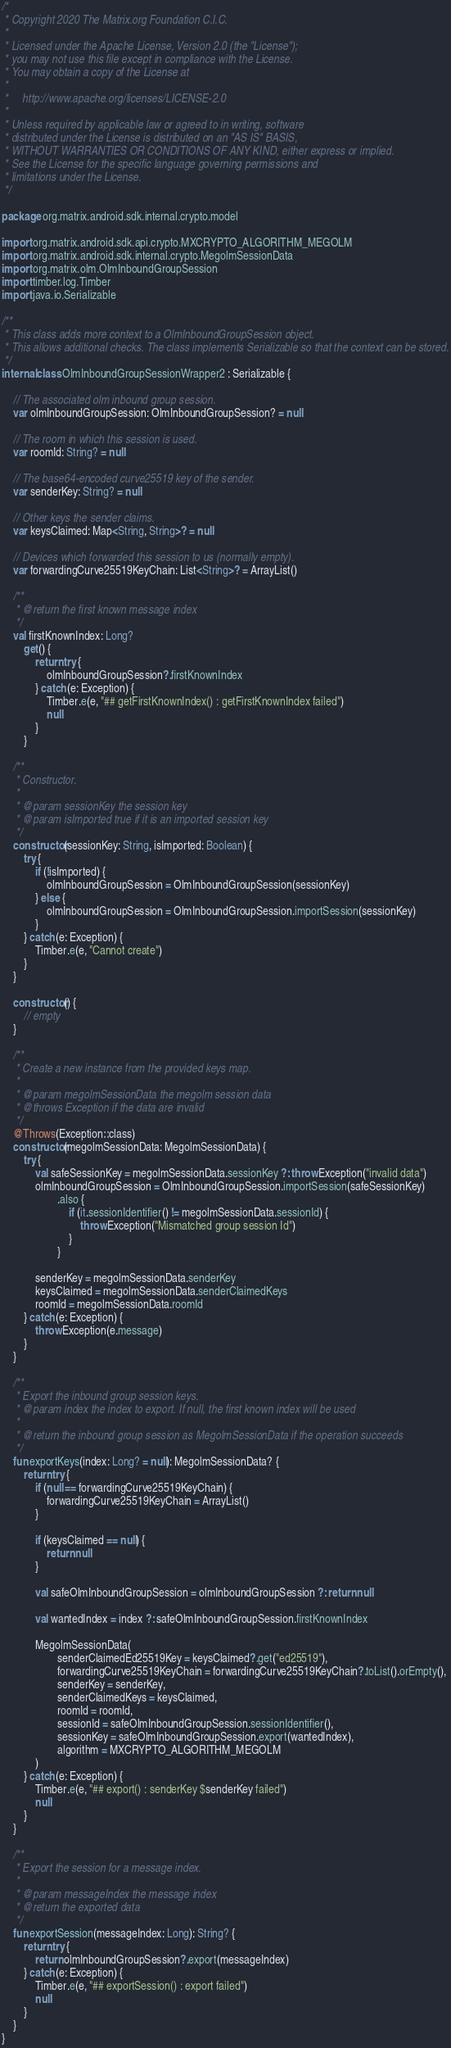Convert code to text. <code><loc_0><loc_0><loc_500><loc_500><_Kotlin_>/*
 * Copyright 2020 The Matrix.org Foundation C.I.C.
 *
 * Licensed under the Apache License, Version 2.0 (the "License");
 * you may not use this file except in compliance with the License.
 * You may obtain a copy of the License at
 *
 *     http://www.apache.org/licenses/LICENSE-2.0
 *
 * Unless required by applicable law or agreed to in writing, software
 * distributed under the License is distributed on an "AS IS" BASIS,
 * WITHOUT WARRANTIES OR CONDITIONS OF ANY KIND, either express or implied.
 * See the License for the specific language governing permissions and
 * limitations under the License.
 */

package org.matrix.android.sdk.internal.crypto.model

import org.matrix.android.sdk.api.crypto.MXCRYPTO_ALGORITHM_MEGOLM
import org.matrix.android.sdk.internal.crypto.MegolmSessionData
import org.matrix.olm.OlmInboundGroupSession
import timber.log.Timber
import java.io.Serializable

/**
 * This class adds more context to a OlmInboundGroupSession object.
 * This allows additional checks. The class implements Serializable so that the context can be stored.
 */
internal class OlmInboundGroupSessionWrapper2 : Serializable {

    // The associated olm inbound group session.
    var olmInboundGroupSession: OlmInboundGroupSession? = null

    // The room in which this session is used.
    var roomId: String? = null

    // The base64-encoded curve25519 key of the sender.
    var senderKey: String? = null

    // Other keys the sender claims.
    var keysClaimed: Map<String, String>? = null

    // Devices which forwarded this session to us (normally empty).
    var forwardingCurve25519KeyChain: List<String>? = ArrayList()

    /**
     * @return the first known message index
     */
    val firstKnownIndex: Long?
        get() {
            return try {
                olmInboundGroupSession?.firstKnownIndex
            } catch (e: Exception) {
                Timber.e(e, "## getFirstKnownIndex() : getFirstKnownIndex failed")
                null
            }
        }

    /**
     * Constructor.
     *
     * @param sessionKey the session key
     * @param isImported true if it is an imported session key
     */
    constructor(sessionKey: String, isImported: Boolean) {
        try {
            if (!isImported) {
                olmInboundGroupSession = OlmInboundGroupSession(sessionKey)
            } else {
                olmInboundGroupSession = OlmInboundGroupSession.importSession(sessionKey)
            }
        } catch (e: Exception) {
            Timber.e(e, "Cannot create")
        }
    }

    constructor() {
        // empty
    }

    /**
     * Create a new instance from the provided keys map.
     *
     * @param megolmSessionData the megolm session data
     * @throws Exception if the data are invalid
     */
    @Throws(Exception::class)
    constructor(megolmSessionData: MegolmSessionData) {
        try {
            val safeSessionKey = megolmSessionData.sessionKey ?: throw Exception("invalid data")
            olmInboundGroupSession = OlmInboundGroupSession.importSession(safeSessionKey)
                    .also {
                        if (it.sessionIdentifier() != megolmSessionData.sessionId) {
                            throw Exception("Mismatched group session Id")
                        }
                    }

            senderKey = megolmSessionData.senderKey
            keysClaimed = megolmSessionData.senderClaimedKeys
            roomId = megolmSessionData.roomId
        } catch (e: Exception) {
            throw Exception(e.message)
        }
    }

    /**
     * Export the inbound group session keys.
     * @param index the index to export. If null, the first known index will be used
     *
     * @return the inbound group session as MegolmSessionData if the operation succeeds
     */
    fun exportKeys(index: Long? = null): MegolmSessionData? {
        return try {
            if (null == forwardingCurve25519KeyChain) {
                forwardingCurve25519KeyChain = ArrayList()
            }

            if (keysClaimed == null) {
                return null
            }

            val safeOlmInboundGroupSession = olmInboundGroupSession ?: return null

            val wantedIndex = index ?: safeOlmInboundGroupSession.firstKnownIndex

            MegolmSessionData(
                    senderClaimedEd25519Key = keysClaimed?.get("ed25519"),
                    forwardingCurve25519KeyChain = forwardingCurve25519KeyChain?.toList().orEmpty(),
                    senderKey = senderKey,
                    senderClaimedKeys = keysClaimed,
                    roomId = roomId,
                    sessionId = safeOlmInboundGroupSession.sessionIdentifier(),
                    sessionKey = safeOlmInboundGroupSession.export(wantedIndex),
                    algorithm = MXCRYPTO_ALGORITHM_MEGOLM
            )
        } catch (e: Exception) {
            Timber.e(e, "## export() : senderKey $senderKey failed")
            null
        }
    }

    /**
     * Export the session for a message index.
     *
     * @param messageIndex the message index
     * @return the exported data
     */
    fun exportSession(messageIndex: Long): String? {
        return try {
            return olmInboundGroupSession?.export(messageIndex)
        } catch (e: Exception) {
            Timber.e(e, "## exportSession() : export failed")
            null
        }
    }
}
</code> 